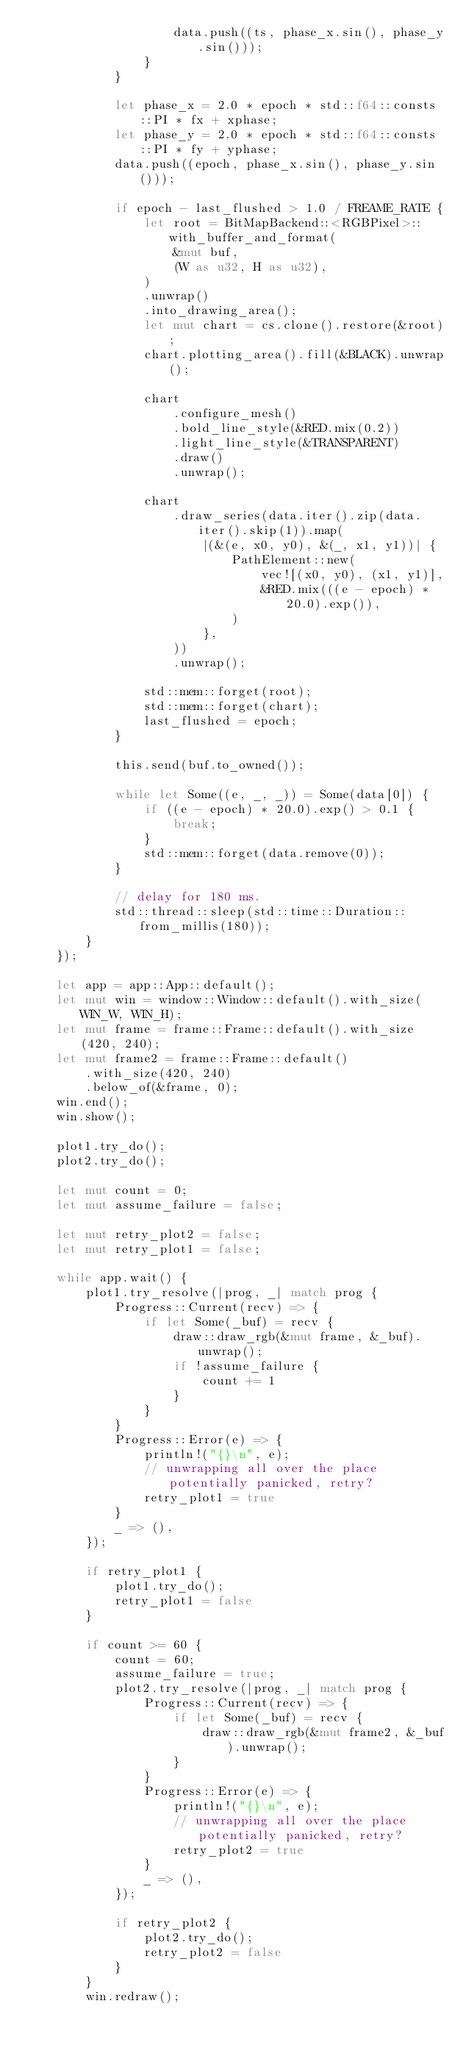Convert code to text. <code><loc_0><loc_0><loc_500><loc_500><_Rust_>                    data.push((ts, phase_x.sin(), phase_y.sin()));
                }
            }

            let phase_x = 2.0 * epoch * std::f64::consts::PI * fx + xphase;
            let phase_y = 2.0 * epoch * std::f64::consts::PI * fy + yphase;
            data.push((epoch, phase_x.sin(), phase_y.sin()));

            if epoch - last_flushed > 1.0 / FREAME_RATE {
                let root = BitMapBackend::<RGBPixel>::with_buffer_and_format(
                    &mut buf,
                    (W as u32, H as u32),
                )
                .unwrap()
                .into_drawing_area();
                let mut chart = cs.clone().restore(&root);
                chart.plotting_area().fill(&BLACK).unwrap();

                chart
                    .configure_mesh()
                    .bold_line_style(&RED.mix(0.2))
                    .light_line_style(&TRANSPARENT)
                    .draw()
                    .unwrap();

                chart
                    .draw_series(data.iter().zip(data.iter().skip(1)).map(
                        |(&(e, x0, y0), &(_, x1, y1))| {
                            PathElement::new(
                                vec![(x0, y0), (x1, y1)],
                                &RED.mix(((e - epoch) * 20.0).exp()),
                            )
                        },
                    ))
                    .unwrap();

                std::mem::forget(root);
                std::mem::forget(chart);
                last_flushed = epoch;
            }

            this.send(buf.to_owned());

            while let Some((e, _, _)) = Some(data[0]) {
                if ((e - epoch) * 20.0).exp() > 0.1 {
                    break;
                }
                std::mem::forget(data.remove(0));
            }

            // delay for 180 ms.
            std::thread::sleep(std::time::Duration::from_millis(180));
        }
    });

    let app = app::App::default();
    let mut win = window::Window::default().with_size(WIN_W, WIN_H);
    let mut frame = frame::Frame::default().with_size(420, 240);
    let mut frame2 = frame::Frame::default()
        .with_size(420, 240)
        .below_of(&frame, 0);
    win.end();
    win.show();

    plot1.try_do();
    plot2.try_do();

    let mut count = 0;
    let mut assume_failure = false;

    let mut retry_plot2 = false;
    let mut retry_plot1 = false;

    while app.wait() {
        plot1.try_resolve(|prog, _| match prog {
            Progress::Current(recv) => {
                if let Some(_buf) = recv {
                    draw::draw_rgb(&mut frame, &_buf).unwrap();
                    if !assume_failure {
                        count += 1
                    }
                }
            }
            Progress::Error(e) => {
                println!("{}\n", e);
                // unwrapping all over the place potentially panicked, retry?
                retry_plot1 = true
            }
            _ => (),
        });

        if retry_plot1 {
            plot1.try_do();
            retry_plot1 = false
        }

        if count >= 60 {
            count = 60;
            assume_failure = true;
            plot2.try_resolve(|prog, _| match prog {
                Progress::Current(recv) => {
                    if let Some(_buf) = recv {
                        draw::draw_rgb(&mut frame2, &_buf).unwrap();
                    }
                }
                Progress::Error(e) => {
                    println!("{}\n", e);
                    // unwrapping all over the place potentially panicked, retry?
                    retry_plot2 = true
                }
                _ => (),
            });

            if retry_plot2 {
                plot2.try_do();
                retry_plot2 = false
            }
        }
        win.redraw();</code> 